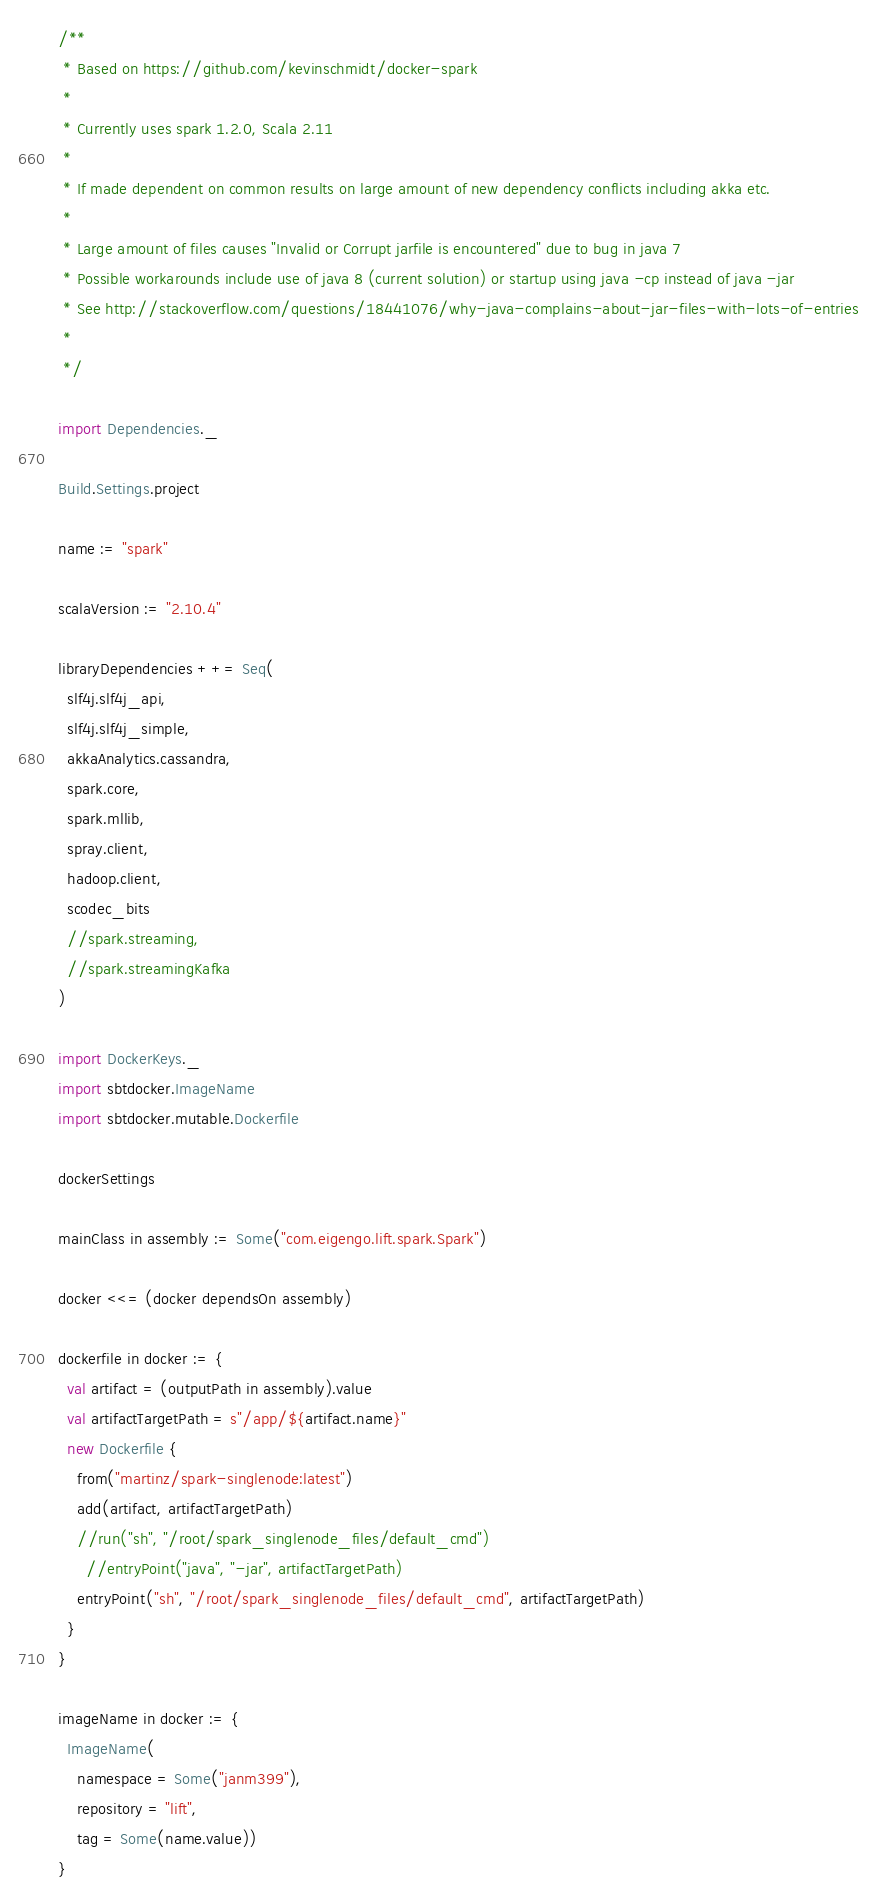<code> <loc_0><loc_0><loc_500><loc_500><_Scala_>/**
 * Based on https://github.com/kevinschmidt/docker-spark
 *
 * Currently uses spark 1.2.0, Scala 2.11
 *
 * If made dependent on common results on large amount of new dependency conflicts including akka etc.
 *
 * Large amount of files causes "Invalid or Corrupt jarfile is encountered" due to bug in java 7
 * Possible workarounds include use of java 8 (current solution) or startup using java -cp instead of java -jar
 * See http://stackoverflow.com/questions/18441076/why-java-complains-about-jar-files-with-lots-of-entries
 *
 */

import Dependencies._

Build.Settings.project

name := "spark"

scalaVersion := "2.10.4"

libraryDependencies ++= Seq(
  slf4j.slf4j_api,
  slf4j.slf4j_simple,
  akkaAnalytics.cassandra,
  spark.core,
  spark.mllib,
  spray.client,
  hadoop.client,
  scodec_bits
  //spark.streaming,
  //spark.streamingKafka
)

import DockerKeys._
import sbtdocker.ImageName
import sbtdocker.mutable.Dockerfile

dockerSettings

mainClass in assembly := Some("com.eigengo.lift.spark.Spark")

docker <<= (docker dependsOn assembly)

dockerfile in docker := {
  val artifact = (outputPath in assembly).value
  val artifactTargetPath = s"/app/${artifact.name}"
  new Dockerfile {
    from("martinz/spark-singlenode:latest")
    add(artifact, artifactTargetPath)
    //run("sh", "/root/spark_singlenode_files/default_cmd")
      //entryPoint("java", "-jar", artifactTargetPath)
    entryPoint("sh", "/root/spark_singlenode_files/default_cmd", artifactTargetPath)
  }
}

imageName in docker := {
  ImageName(
    namespace = Some("janm399"),
    repository = "lift",
    tag = Some(name.value))
}</code> 